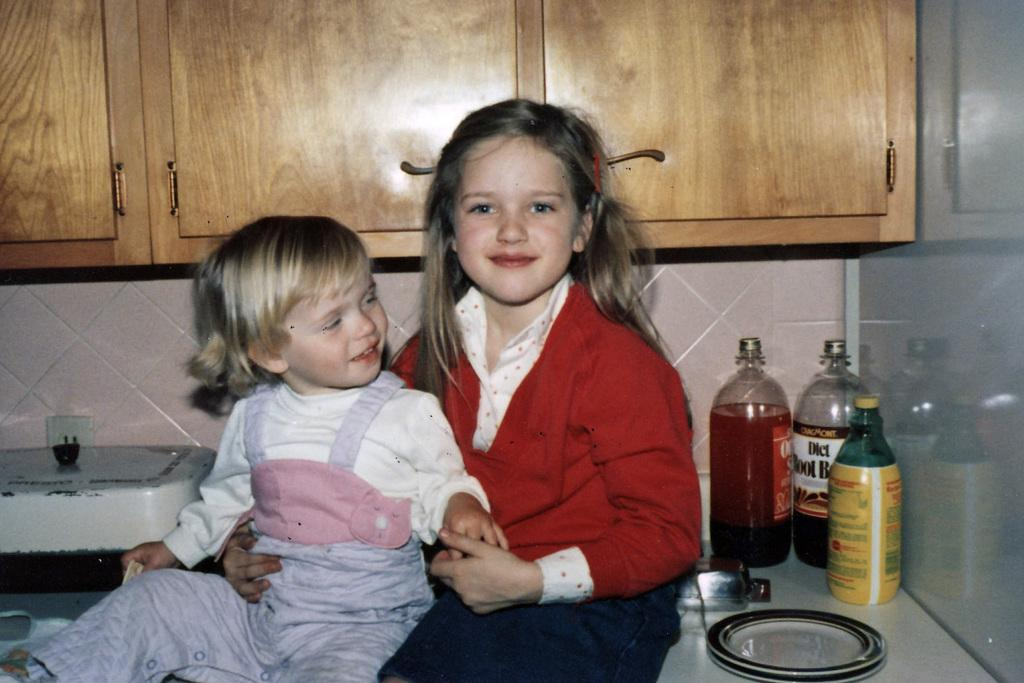<image>
Relay a brief, clear account of the picture shown. Two young girls sit on a counter near a bottle of diet root beer 